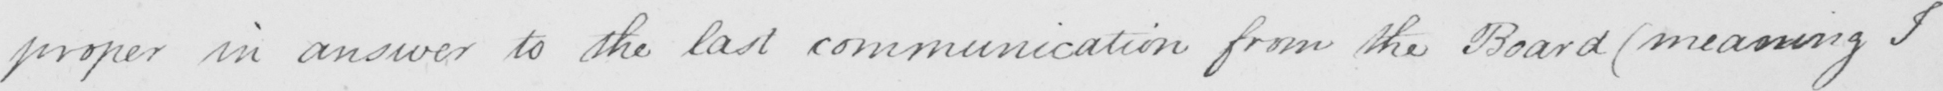Can you tell me what this handwritten text says? proper in answer to the last communication from the Board  ( meaning I 